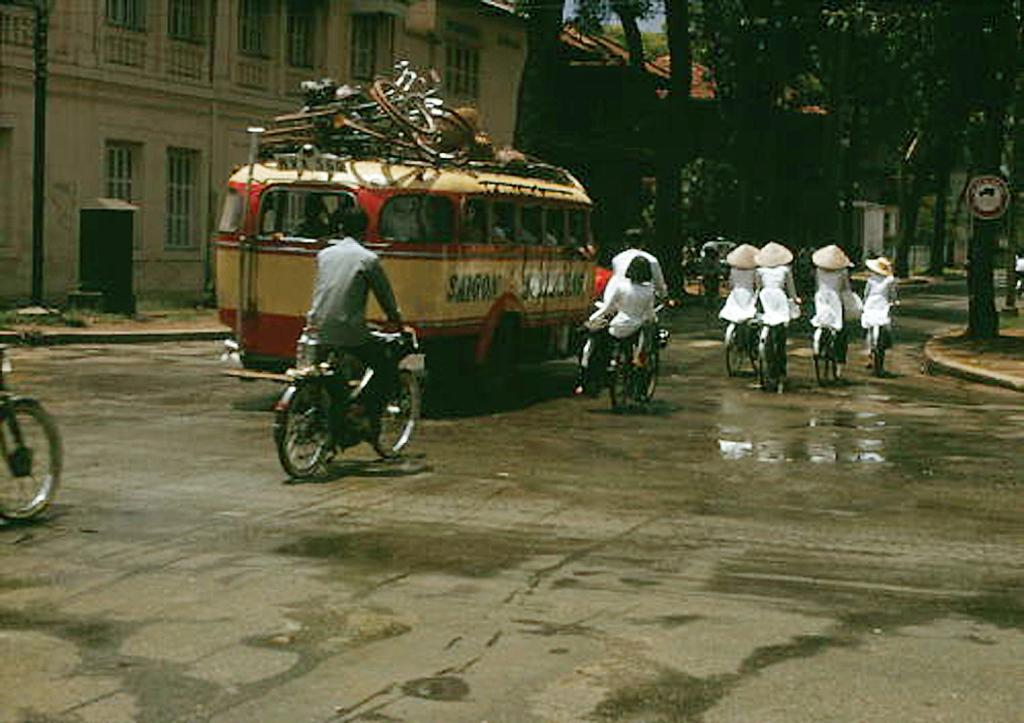What are the people in the image doing? The people in the image are riding bicycles. What else can be seen in the image besides the people on bicycles? There are vehicles and buildings in the background of the image. What type of vegetation is visible in the background? There are trees in the background of the image. What is the color of the sky in the image? The sky is blue in the image. Where is the stove located in the image? There is no stove present in the image. What type of belief can be seen in the image? There is no belief depicted in the image; it features people riding bicycles, vehicles, buildings, trees, and a blue sky. 